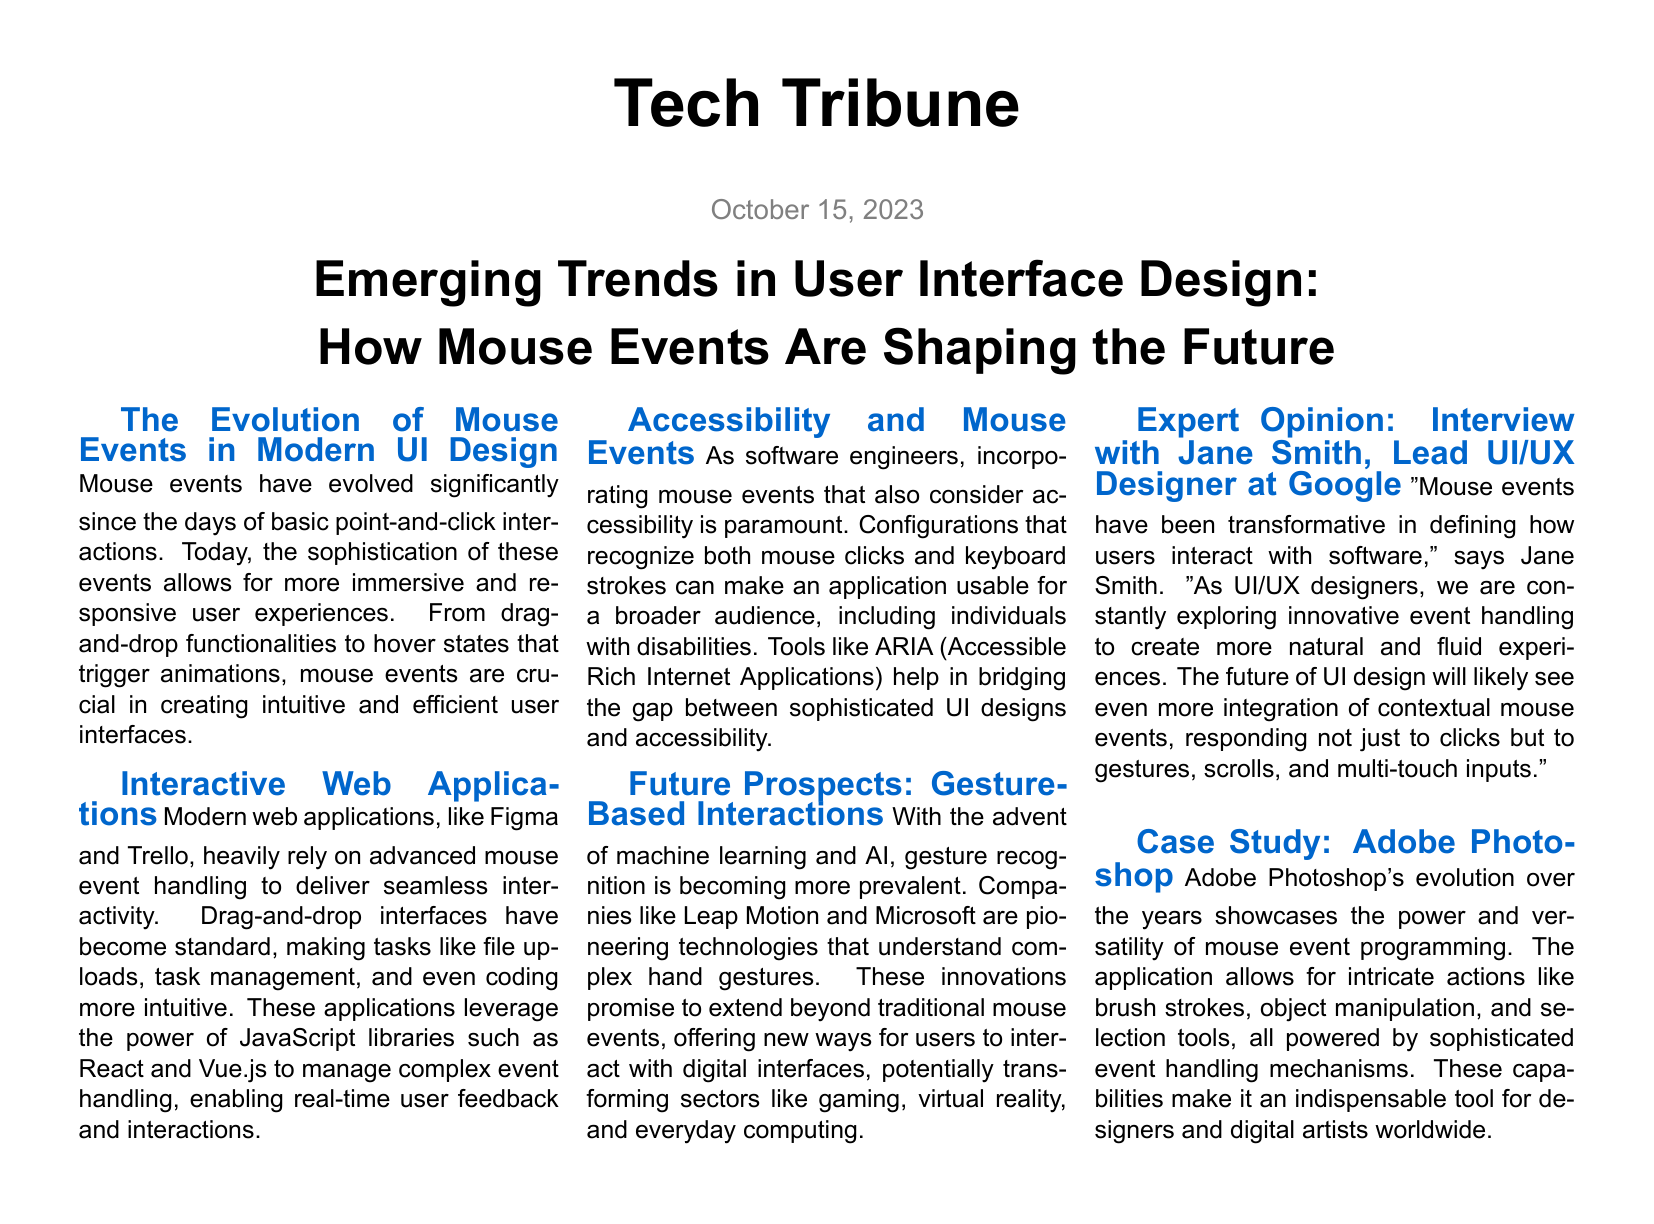What is the title of the article? The title of the article is stated in bold at the top of the document.
Answer: How Mouse Events Are Shaping the Future Who is the Lead UI/UX Designer at Google mentioned in the article? Jane Smith is introduced as the Lead UI/UX Designer at Google in the expert opinion section.
Answer: Jane Smith What date is the article published? The publication date is indicated below the title and is formatted as the date of issue.
Answer: October 15, 2023 Which two web applications are mentioned as relying on advanced mouse event handling? The document lists these specific applications in the context of interactive web interfaces.
Answer: Figma and Trello What technology is being pioneered by companies like Leap Motion and Microsoft? This technology is discussed in relation to the future of mouse events in the article.
Answer: Gesture recognition What is the focus of the case study highlighted in the document? The case study summarizes the evolution and capabilities of a specific software application.
Answer: Adobe Photoshop Which tool is mentioned that aids in making applications accessible? The document discusses tools necessary for improving accessibility in software design.
Answer: ARIA What is a key trend in the future of UI design according to Jane Smith? Jane Smith emphasizes a particular aspect of design that is expected to grow in relevance in the future.
Answer: Contextual mouse events 